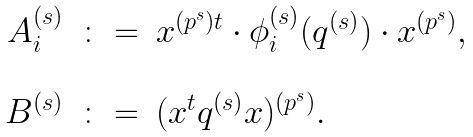Convert formula to latex. <formula><loc_0><loc_0><loc_500><loc_500>\begin{array} { r c l } A _ { i } ^ { ( s ) } & \colon = & x ^ { ( p ^ { s } ) t } \cdot \phi ^ { ( s ) } _ { i } ( q ^ { ( s ) } ) \cdot x ^ { ( p ^ { s } ) } , \\ \ & \ & \ \\ B ^ { ( s ) } & \colon = & ( x ^ { t } q ^ { ( s ) } x ) ^ { ( p ^ { s } ) } . \end{array}</formula> 